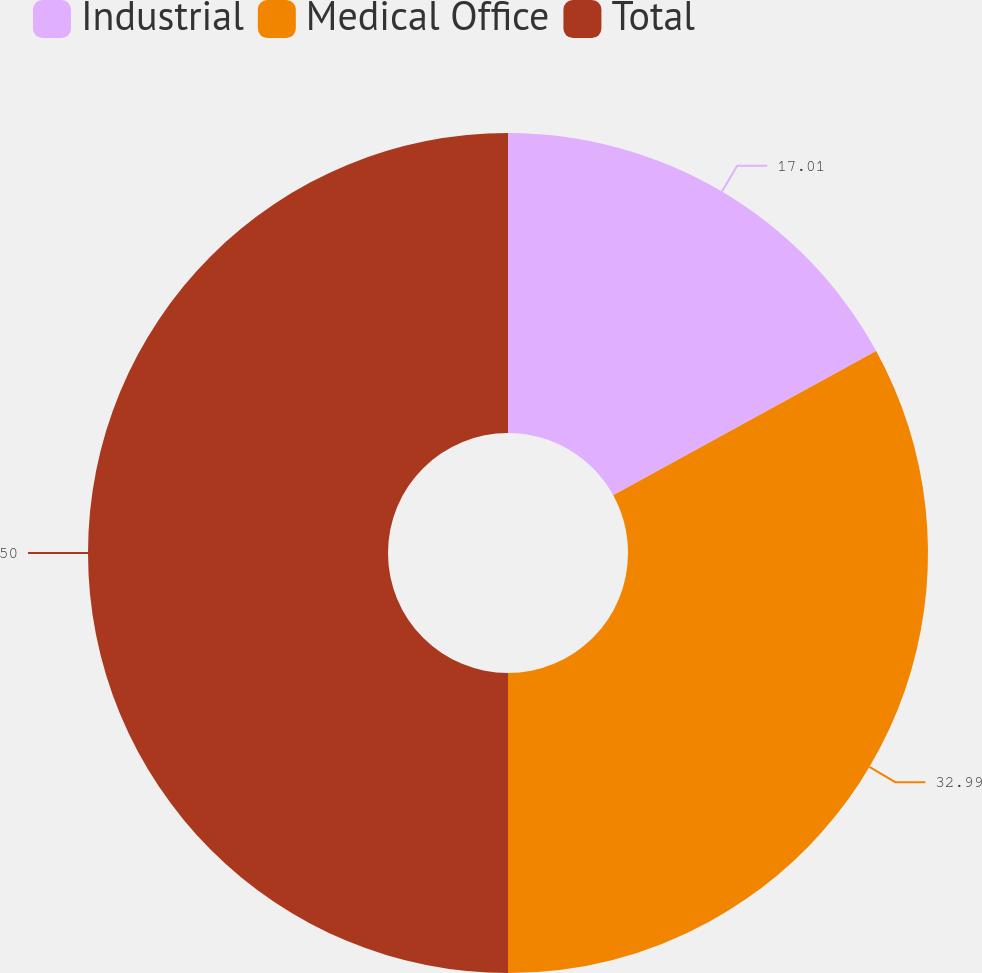<chart> <loc_0><loc_0><loc_500><loc_500><pie_chart><fcel>Industrial<fcel>Medical Office<fcel>Total<nl><fcel>17.01%<fcel>32.99%<fcel>50.0%<nl></chart> 